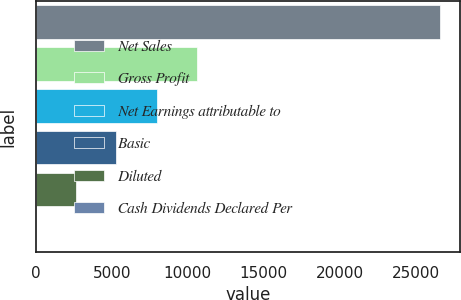Convert chart to OTSL. <chart><loc_0><loc_0><loc_500><loc_500><bar_chart><fcel>Net Sales<fcel>Gross Profit<fcel>Net Earnings attributable to<fcel>Basic<fcel>Diluted<fcel>Cash Dividends Declared Per<nl><fcel>26573<fcel>10629.4<fcel>7972.15<fcel>5314.88<fcel>2657.61<fcel>0.34<nl></chart> 